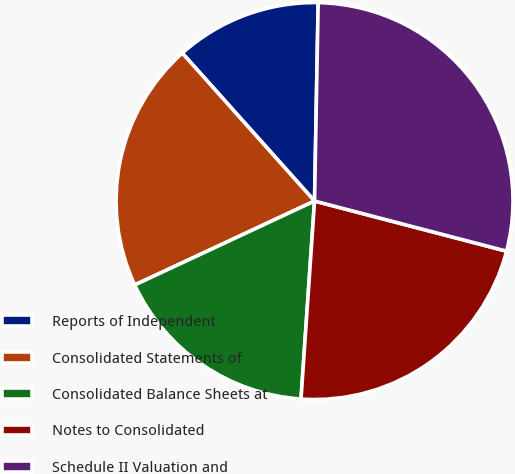Convert chart to OTSL. <chart><loc_0><loc_0><loc_500><loc_500><pie_chart><fcel>Reports of Independent<fcel>Consolidated Statements of<fcel>Consolidated Balance Sheets at<fcel>Notes to Consolidated<fcel>Schedule II Valuation and<nl><fcel>11.9%<fcel>20.34%<fcel>16.96%<fcel>22.02%<fcel>28.77%<nl></chart> 